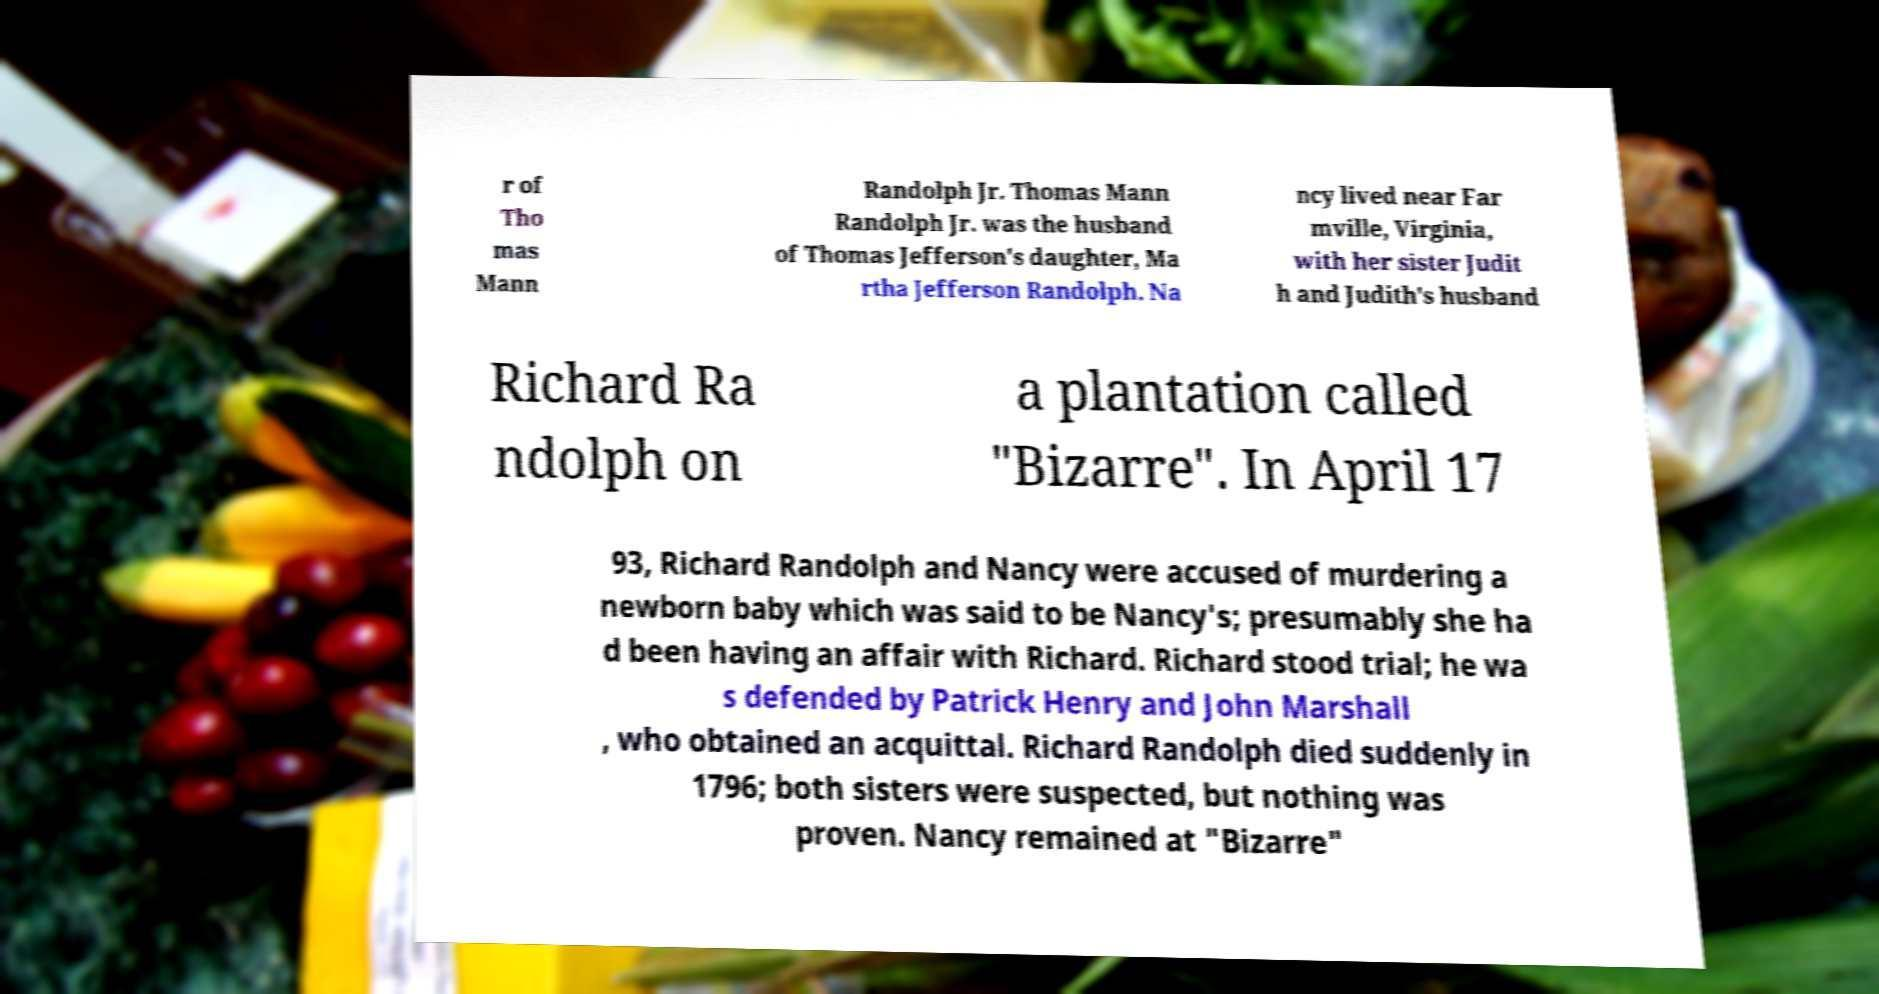I need the written content from this picture converted into text. Can you do that? r of Tho mas Mann Randolph Jr. Thomas Mann Randolph Jr. was the husband of Thomas Jefferson's daughter, Ma rtha Jefferson Randolph. Na ncy lived near Far mville, Virginia, with her sister Judit h and Judith's husband Richard Ra ndolph on a plantation called "Bizarre". In April 17 93, Richard Randolph and Nancy were accused of murdering a newborn baby which was said to be Nancy's; presumably she ha d been having an affair with Richard. Richard stood trial; he wa s defended by Patrick Henry and John Marshall , who obtained an acquittal. Richard Randolph died suddenly in 1796; both sisters were suspected, but nothing was proven. Nancy remained at "Bizarre" 